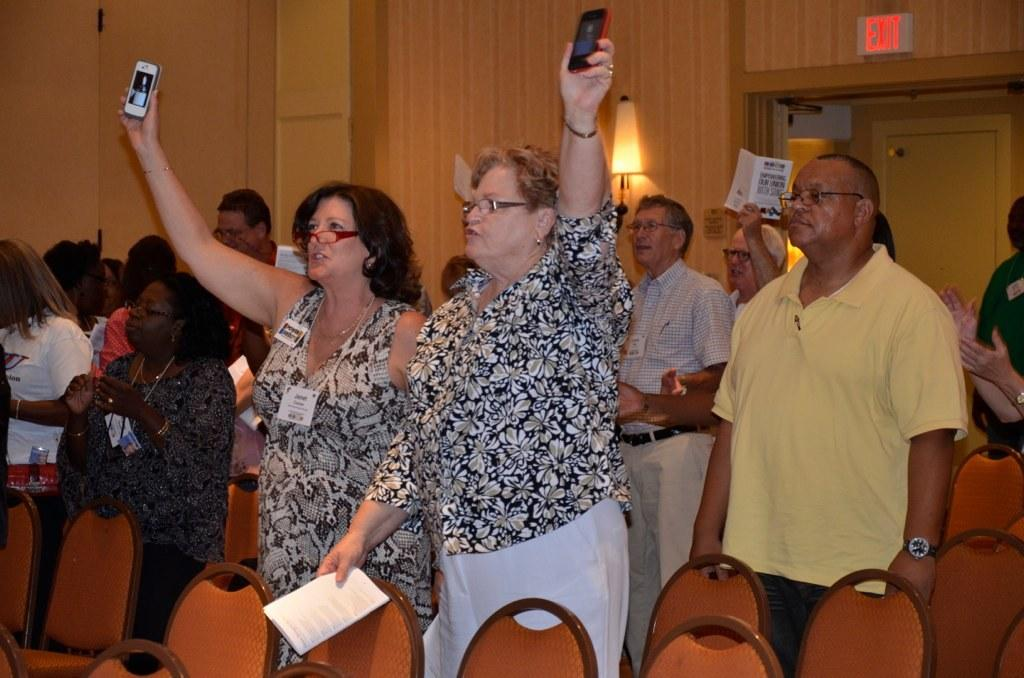How many people are present in the room in the image? There are many people standing in the room in the image. What are the people doing in the image? The people are responding to something. What can be seen in the background of the room? There is a wooden wall in the background. Where is the exit door located in the room? The exit door is beside the wooden wall. What type of cream is being served on the table in the image? There is no table or cream present in the image. Who is the brother of the person standing in the image? There is no information about a brother or any specific person in the image. 